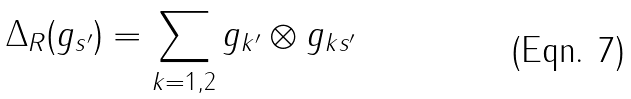Convert formula to latex. <formula><loc_0><loc_0><loc_500><loc_500>\Delta _ { R } ( g _ { s ^ { \prime } } ) = \sum _ { k = 1 , 2 } g _ { k ^ { \prime } } \otimes g _ { k s ^ { \prime } }</formula> 